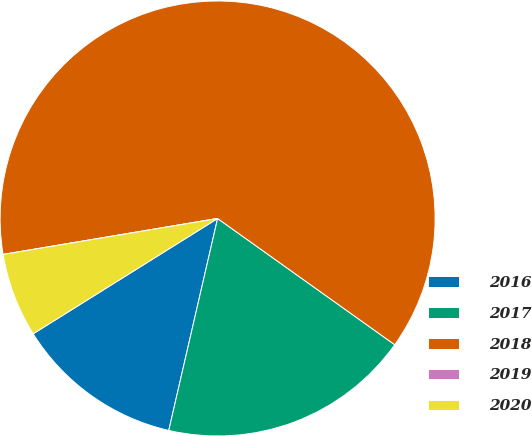<chart> <loc_0><loc_0><loc_500><loc_500><pie_chart><fcel>2016<fcel>2017<fcel>2018<fcel>2019<fcel>2020<nl><fcel>12.5%<fcel>18.75%<fcel>62.49%<fcel>0.0%<fcel>6.25%<nl></chart> 